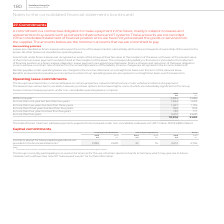From Vodafone Group Plc's financial document, Which financial years' information is shown in the table? The document shows two values: 2018 and 2019. From the document: "2019 2018 €m €m Within one year 2,834 2,686 In more than one year but less than two years 1,654 1,633 In 2019 2018 €m €m Within one year 2,834 2,686 I..." Also, How much is the 2019 total future minimum lease payments under non-cancellable operating leases? According to the financial document, 10,816 (in millions). The relevant text states: "years 739 717 In more than five years 3,412 2,600 10,816 9,694..." Also, How much is the 2018 total future minimum lease payments under non-cancellable operating leases? According to the financial document, 9,694 (in millions). The relevant text states: "39 717 In more than five years 3,412 2,600 10,816 9,694..." Additionally, Between 2018 and 2019, which year had higher total future minimum lease payments under non-cancellable operating leases? According to the financial document, 2019. The relevant text states: "2019 2018 €m €m Within one year 2,834 2,686 In more than one year but less than two years 1,654 1,633 In..." Also, can you calculate: How much did future minimum lease payments due within one year change by between 2018 and 2019? Based on the calculation: 2,834-2,686, the result is 148 (in millions). This is based on the information: "2019 2018 €m €m Within one year 2,834 2,686 In more than one year but less than two years 1,654 1,633 In more than two years but less tha 2019 2018 €m €m Within one year 2,834 2,686 In more than one y..." The key data points involved are: 2,686, 2,834. Additionally, Between 2018 and 2019, which year had higher future minimum lease payments due within one year? According to the financial document, 2019. The relevant text states: "2019 2018 €m €m Within one year 2,834 2,686 In more than one year but less than two years 1,654 1,633 In..." 